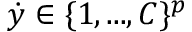Convert formula to latex. <formula><loc_0><loc_0><loc_500><loc_500>\dot { y } \in \{ 1 , \dots , C \} ^ { p }</formula> 